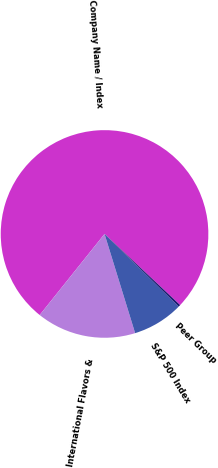<chart> <loc_0><loc_0><loc_500><loc_500><pie_chart><fcel>Company Name / Index<fcel>International Flavors &<fcel>S&P 500 Index<fcel>Peer Group<nl><fcel>76.28%<fcel>15.5%<fcel>7.91%<fcel>0.31%<nl></chart> 